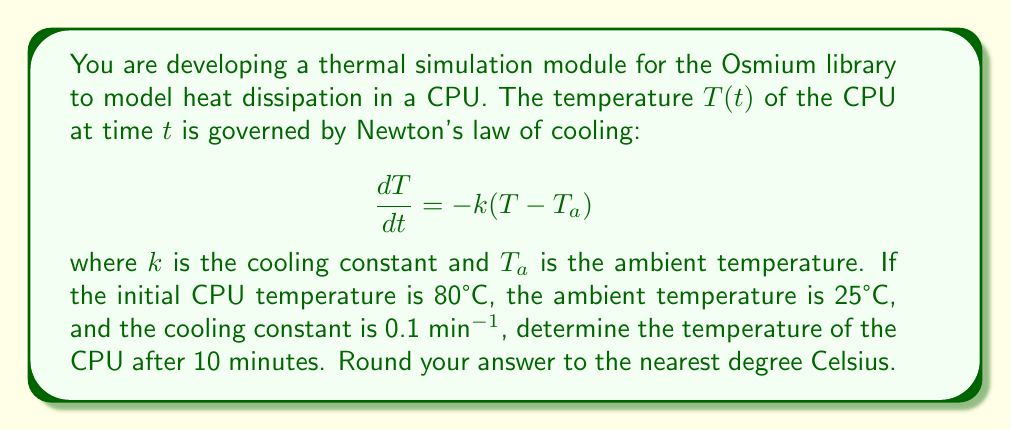Give your solution to this math problem. To solve this problem, we need to follow these steps:

1) The general solution for Newton's law of cooling is:

   $$T(t) = T_a + (T_0 - T_a)e^{-kt}$$

   where $T_0$ is the initial temperature.

2) We are given:
   - $T_0 = 80°C$ (initial CPU temperature)
   - $T_a = 25°C$ (ambient temperature)
   - $k = 0.1$ min^(-1) (cooling constant)
   - $t = 10$ minutes (time elapsed)

3) Substituting these values into the equation:

   $$T(10) = 25 + (80 - 25)e^{-0.1 \cdot 10}$$

4) Simplify:
   $$T(10) = 25 + 55e^{-1}$$

5) Calculate:
   $$T(10) = 25 + 55 \cdot 0.3679$$
   $$T(10) = 25 + 20.23$$
   $$T(10) = 45.23°C$$

6) Rounding to the nearest degree:
   $$T(10) \approx 45°C$$
Answer: 45°C 